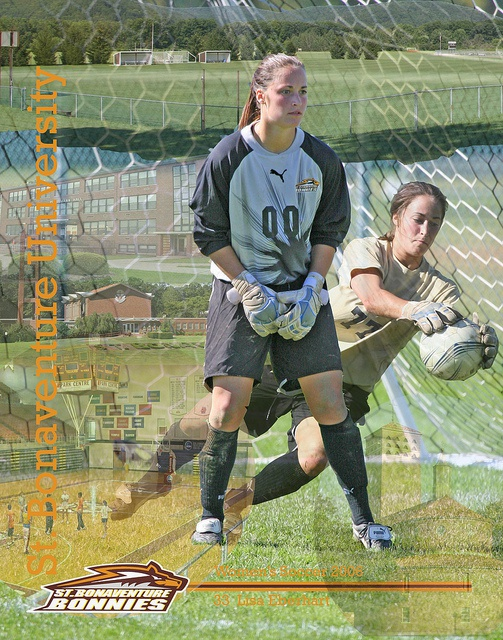Describe the objects in this image and their specific colors. I can see people in gray, black, and darkgray tones, people in gray, black, ivory, and darkgreen tones, sports ball in gray, ivory, and darkgray tones, and baseball glove in gray, lightgray, darkgray, and tan tones in this image. 